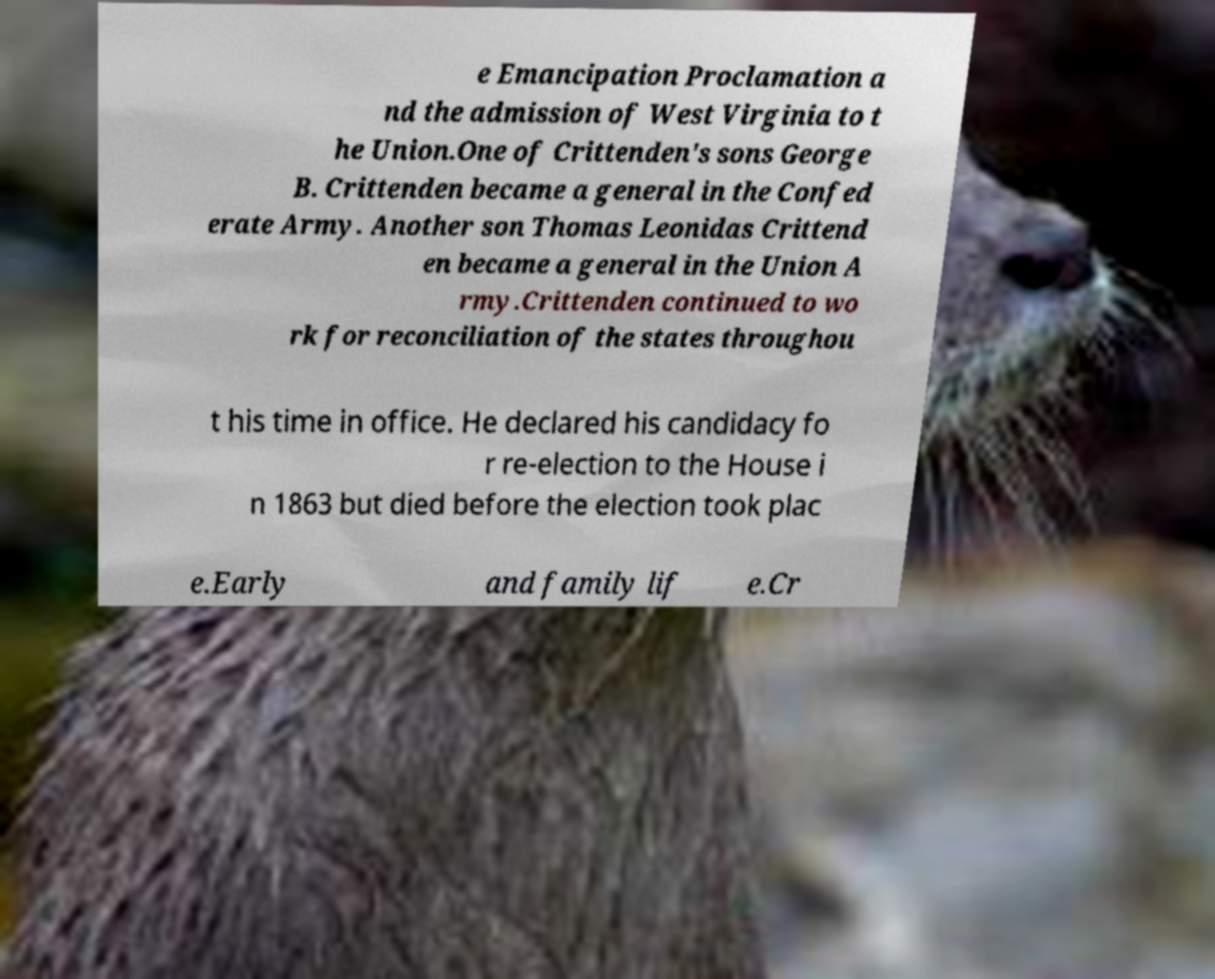Please read and relay the text visible in this image. What does it say? e Emancipation Proclamation a nd the admission of West Virginia to t he Union.One of Crittenden's sons George B. Crittenden became a general in the Confed erate Army. Another son Thomas Leonidas Crittend en became a general in the Union A rmy.Crittenden continued to wo rk for reconciliation of the states throughou t his time in office. He declared his candidacy fo r re-election to the House i n 1863 but died before the election took plac e.Early and family lif e.Cr 